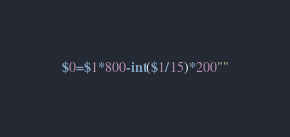Convert code to text. <code><loc_0><loc_0><loc_500><loc_500><_Awk_>$0=$1*800-int($1/15)*200""</code> 